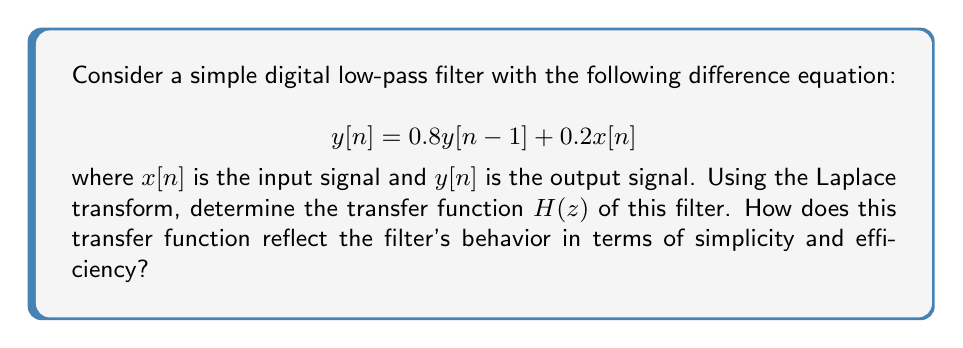Give your solution to this math problem. Let's approach this step-by-step:

1) First, we need to take the Z-transform of both sides of the difference equation:

   $$Z\{y[n]\} = 0.8Z\{y[n-1]\} + 0.2Z\{x[n]\}$$

2) Using the time-shift property of Z-transforms, we know that:
   
   $$Z\{y[n-1]\} = z^{-1}Y(z)$$

3) Substituting this into our equation:

   $$Y(z) = 0.8z^{-1}Y(z) + 0.2X(z)$$

4) Now, let's solve for $Y(z)$:

   $$Y(z) - 0.8z^{-1}Y(z) = 0.2X(z)$$
   $$Y(z)(1 - 0.8z^{-1}) = 0.2X(z)$$
   $$Y(z) = \frac{0.2}{1 - 0.8z^{-1}}X(z)$$

5) The transfer function $H(z)$ is defined as the ratio of output to input in the Z-domain:

   $$H(z) = \frac{Y(z)}{X(z)} = \frac{0.2}{1 - 0.8z^{-1}}$$

6) This transfer function reflects the filter's simplicity and efficiency in several ways:
   
   a) It only has one pole at $z = 0.8$, which means it's a first-order filter, the simplest possible IIR filter.
   
   b) The coefficients (0.2 and 0.8) sum to 1, ensuring stability and unity gain at DC.
   
   c) The filter requires only two multiplications and one addition per output sample, making it computationally efficient.
   
   d) The structure of the transfer function (a constant divided by a linear term in $z^{-1}$) is typical of simple low-pass filters, effectively attenuating high-frequency components.
Answer: The transfer function of the digital filter is:

$$H(z) = \frac{0.2}{1 - 0.8z^{-1}}$$

This simple first-order transfer function reflects the filter's efficiency through its minimal computational requirements and its simplicity through its clear low-pass characteristics and stability. 